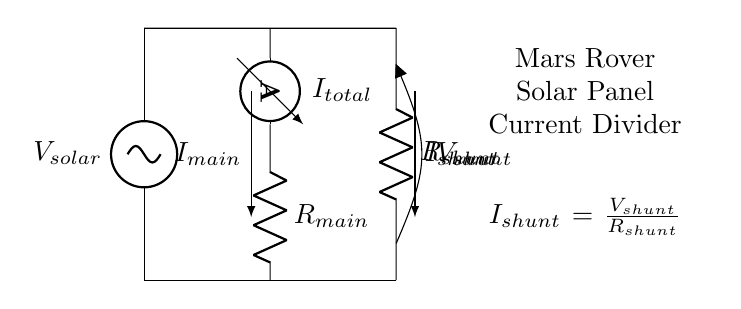What is the total current in this circuit? The total current in the circuit is shown as I total next to the ammeter in the diagram.
Answer: I total What type of component is R main? R main is a resistor, identified as a component in the circuit providing resistance in the main current path.
Answer: Resistor What is the current through the shunt resistor? The current through the shunt resistor is defined as I shunt, which is calculated based on the voltage across the shunt and its resistance (I shunt equals V shunt divided by R shunt).
Answer: I shunt What measurement is taken across the shunt resistor? The measurement taken across the shunt resistor is V shunt, which indicates the voltage drop across R shunt and is vital for calculating the shunt current.
Answer: V shunt What is the role of a current divider in this circuit? The role of a current divider is to split the total current in the circuit between the main path and the shunt, allowing for monitoring and measurement of the electrical characteristics of the solar panel system.
Answer: Current division 